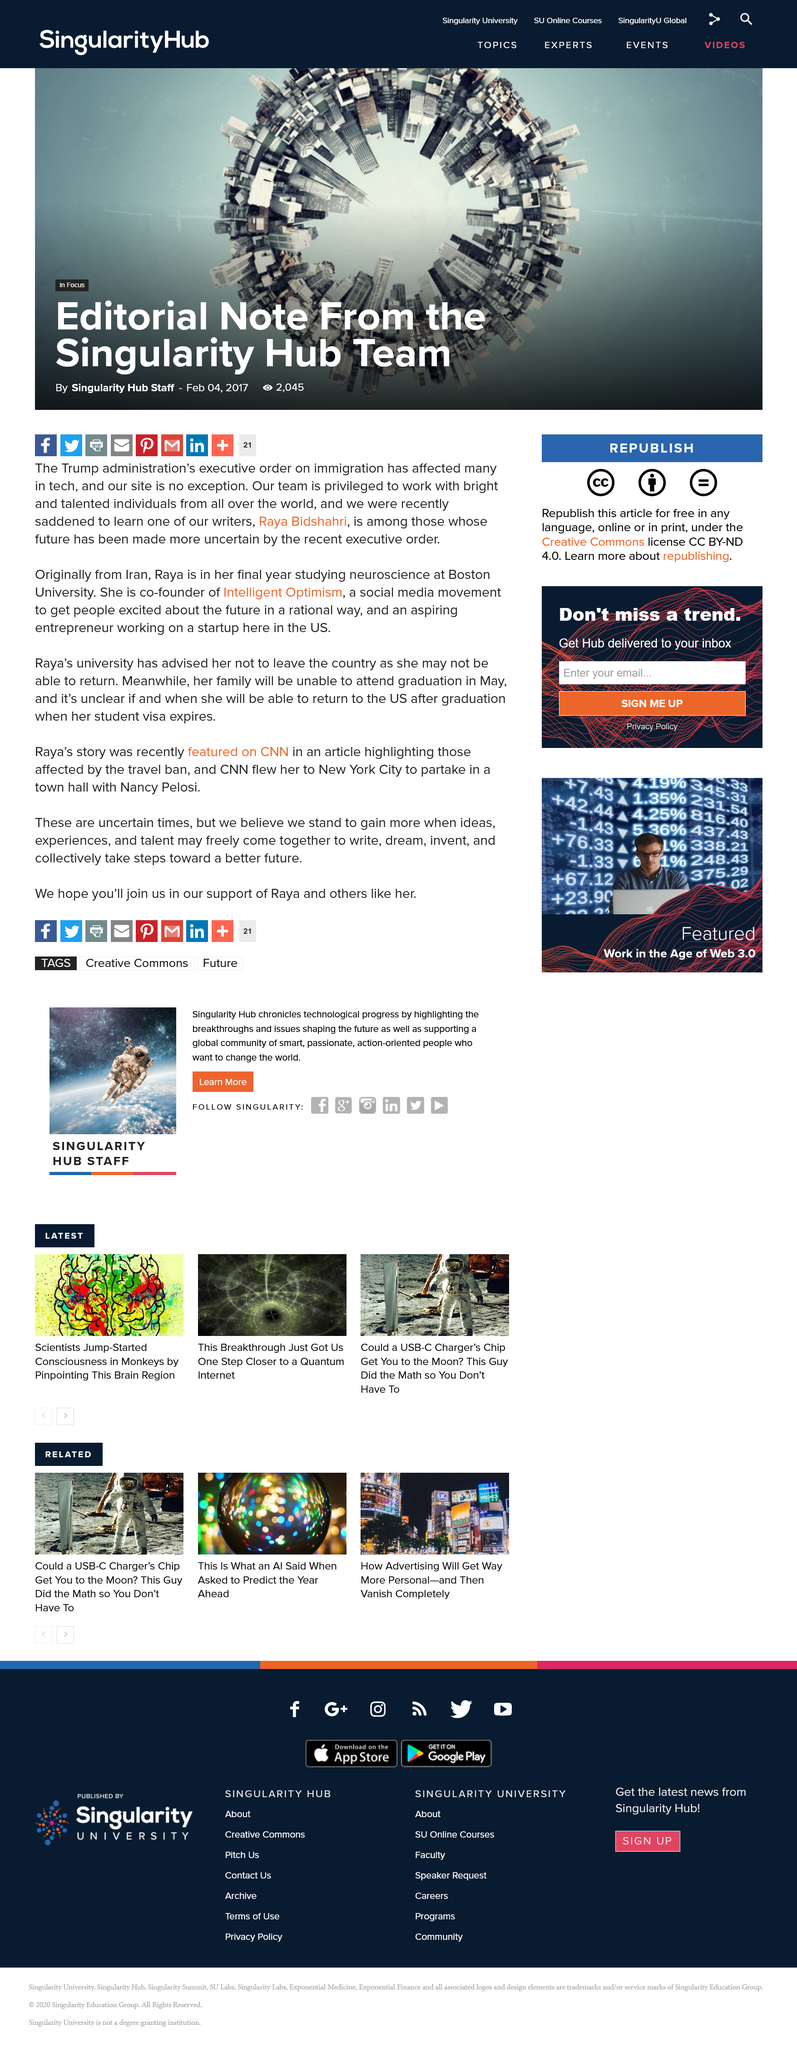Point out several critical features in this image. The note is from the Singularity Hub Team. This article can be shared on various social media platforms such as Facebook, Twitter, Pinterest, Gmail, and LinkedIn. The writer about whom this not is written is Raya Bidshahri. 